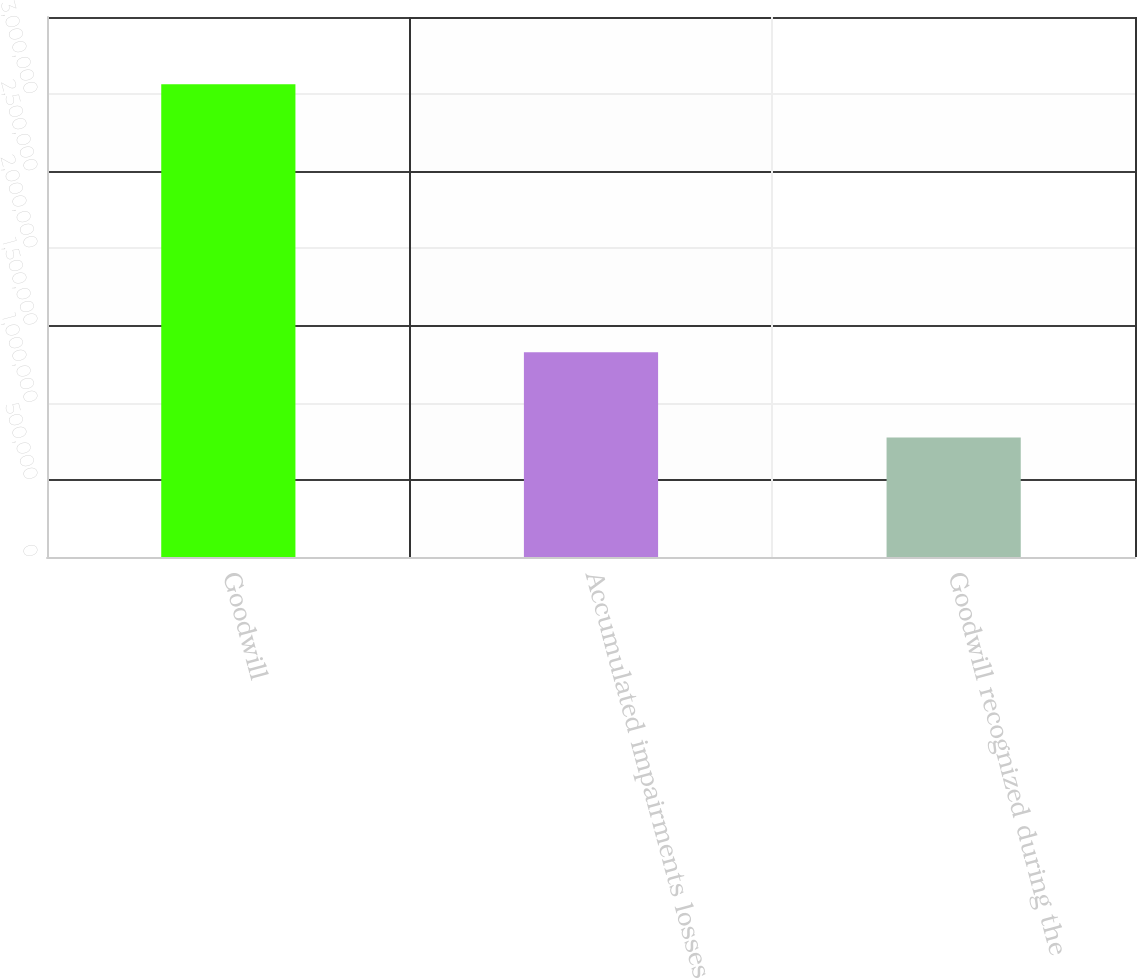<chart> <loc_0><loc_0><loc_500><loc_500><bar_chart><fcel>Goodwill<fcel>Accumulated impairments losses<fcel>Goodwill recognized during the<nl><fcel>3.06352e+06<fcel>1.32742e+06<fcel>775154<nl></chart> 